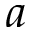<formula> <loc_0><loc_0><loc_500><loc_500>a</formula> 